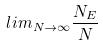Convert formula to latex. <formula><loc_0><loc_0><loc_500><loc_500>l i m _ { N \rightarrow \infty } \frac { N _ { E } } { N }</formula> 